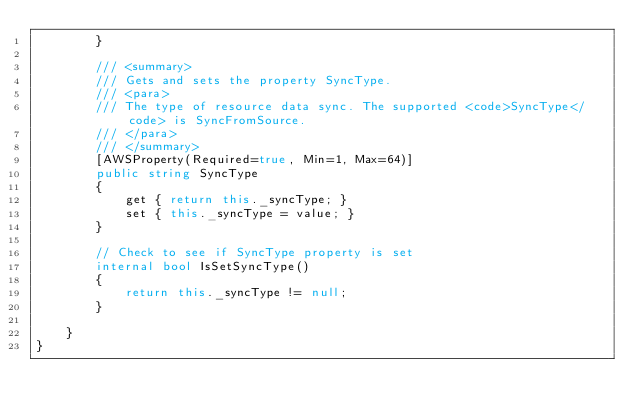Convert code to text. <code><loc_0><loc_0><loc_500><loc_500><_C#_>        }

        /// <summary>
        /// Gets and sets the property SyncType. 
        /// <para>
        /// The type of resource data sync. The supported <code>SyncType</code> is SyncFromSource.
        /// </para>
        /// </summary>
        [AWSProperty(Required=true, Min=1, Max=64)]
        public string SyncType
        {
            get { return this._syncType; }
            set { this._syncType = value; }
        }

        // Check to see if SyncType property is set
        internal bool IsSetSyncType()
        {
            return this._syncType != null;
        }

    }
}</code> 